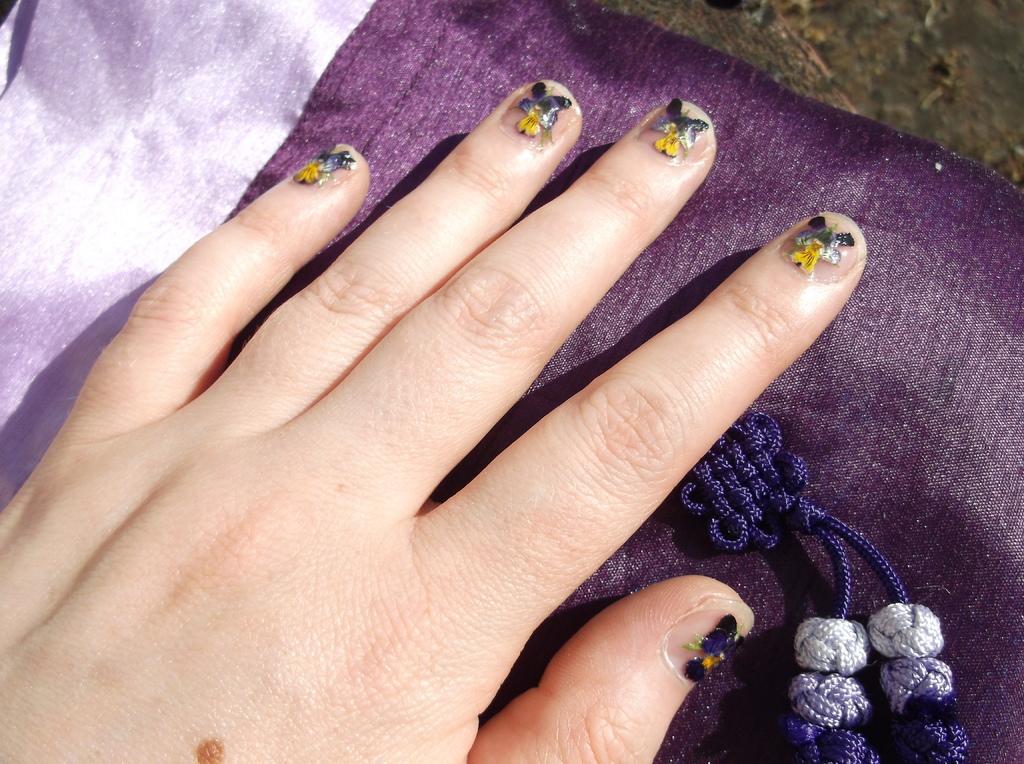Can you describe this image briefly? In this image, we can see the palm of a person. The person's nails are covered with nail art, the palm is kept on the cloth. 